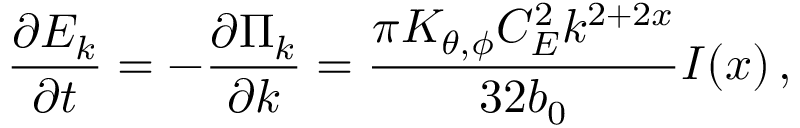Convert formula to latex. <formula><loc_0><loc_0><loc_500><loc_500>\frac { \partial E _ { k } } { \partial t } = - \frac { \partial \Pi _ { k } } { \partial k } = \frac { \pi K _ { \theta , \phi } C _ { E } ^ { 2 } k ^ { 2 + 2 x } } { 3 2 b _ { 0 } } I ( x ) \, ,</formula> 